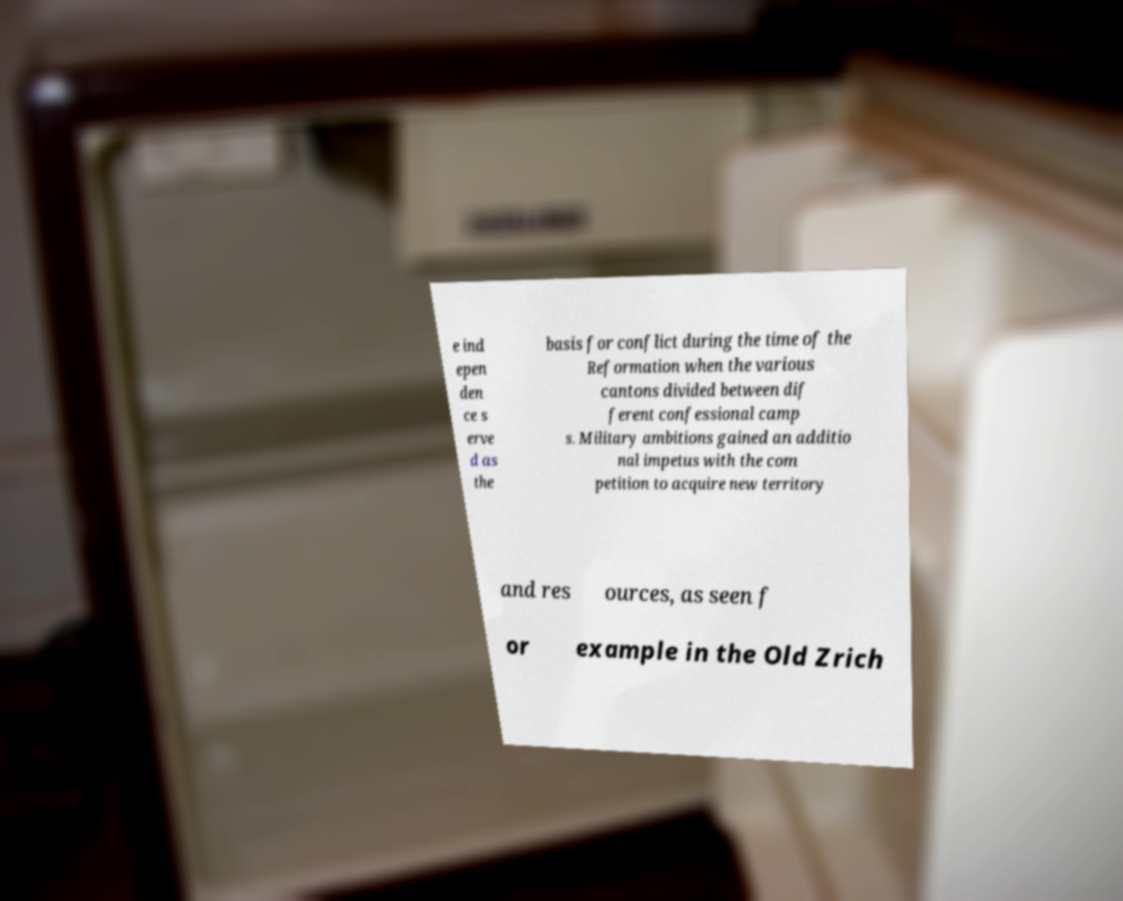I need the written content from this picture converted into text. Can you do that? e ind epen den ce s erve d as the basis for conflict during the time of the Reformation when the various cantons divided between dif ferent confessional camp s. Military ambitions gained an additio nal impetus with the com petition to acquire new territory and res ources, as seen f or example in the Old Zrich 